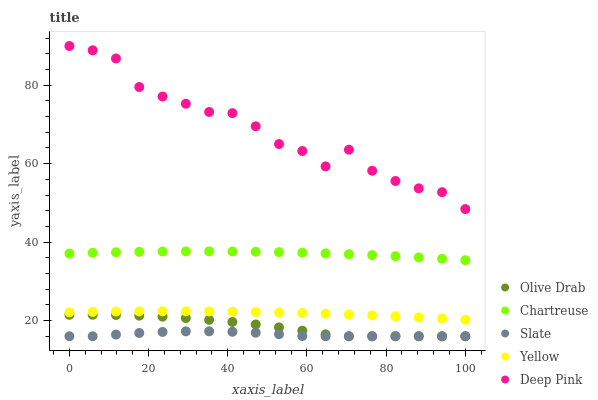Does Slate have the minimum area under the curve?
Answer yes or no. Yes. Does Deep Pink have the maximum area under the curve?
Answer yes or no. Yes. Does Yellow have the minimum area under the curve?
Answer yes or no. No. Does Yellow have the maximum area under the curve?
Answer yes or no. No. Is Yellow the smoothest?
Answer yes or no. Yes. Is Deep Pink the roughest?
Answer yes or no. Yes. Is Deep Pink the smoothest?
Answer yes or no. No. Is Yellow the roughest?
Answer yes or no. No. Does Slate have the lowest value?
Answer yes or no. Yes. Does Yellow have the lowest value?
Answer yes or no. No. Does Deep Pink have the highest value?
Answer yes or no. Yes. Does Yellow have the highest value?
Answer yes or no. No. Is Olive Drab less than Chartreuse?
Answer yes or no. Yes. Is Chartreuse greater than Olive Drab?
Answer yes or no. Yes. Does Slate intersect Olive Drab?
Answer yes or no. Yes. Is Slate less than Olive Drab?
Answer yes or no. No. Is Slate greater than Olive Drab?
Answer yes or no. No. Does Olive Drab intersect Chartreuse?
Answer yes or no. No. 